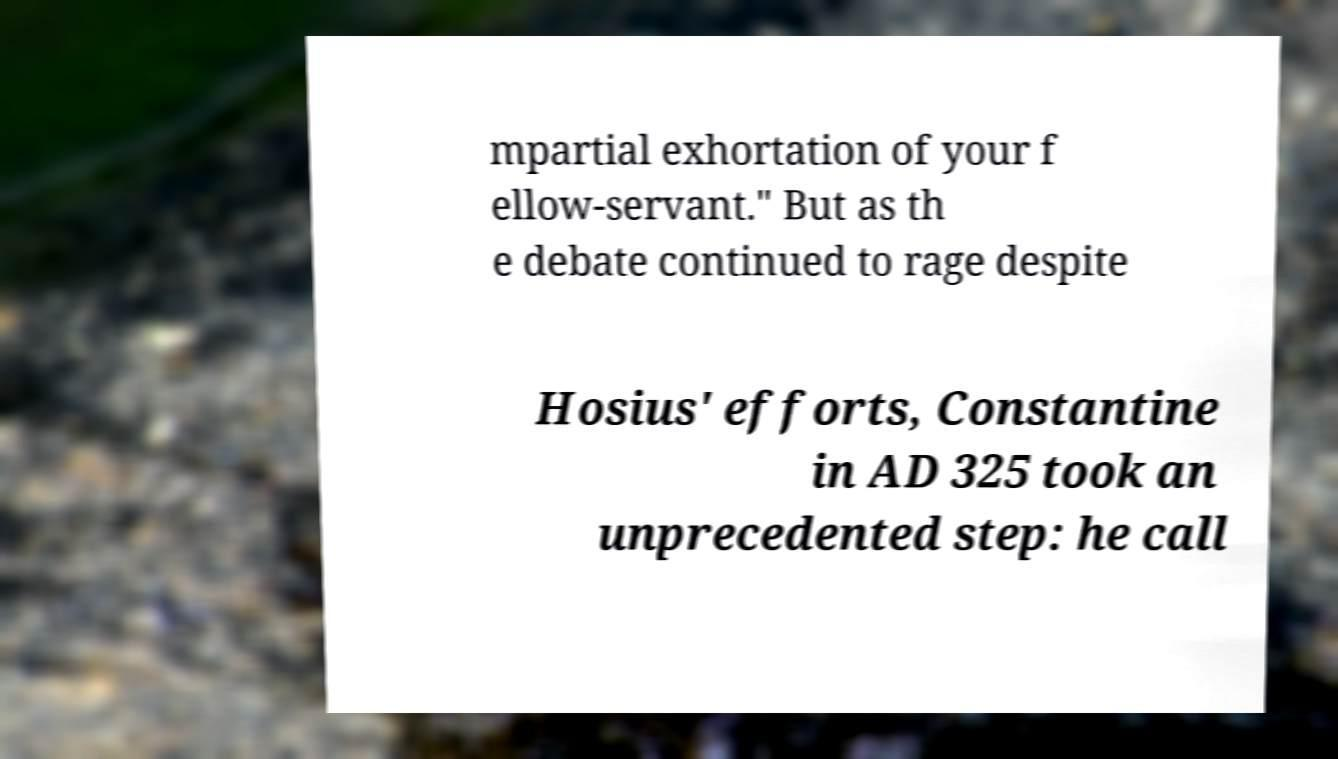Please read and relay the text visible in this image. What does it say? mpartial exhortation of your f ellow-servant." But as th e debate continued to rage despite Hosius' efforts, Constantine in AD 325 took an unprecedented step: he call 